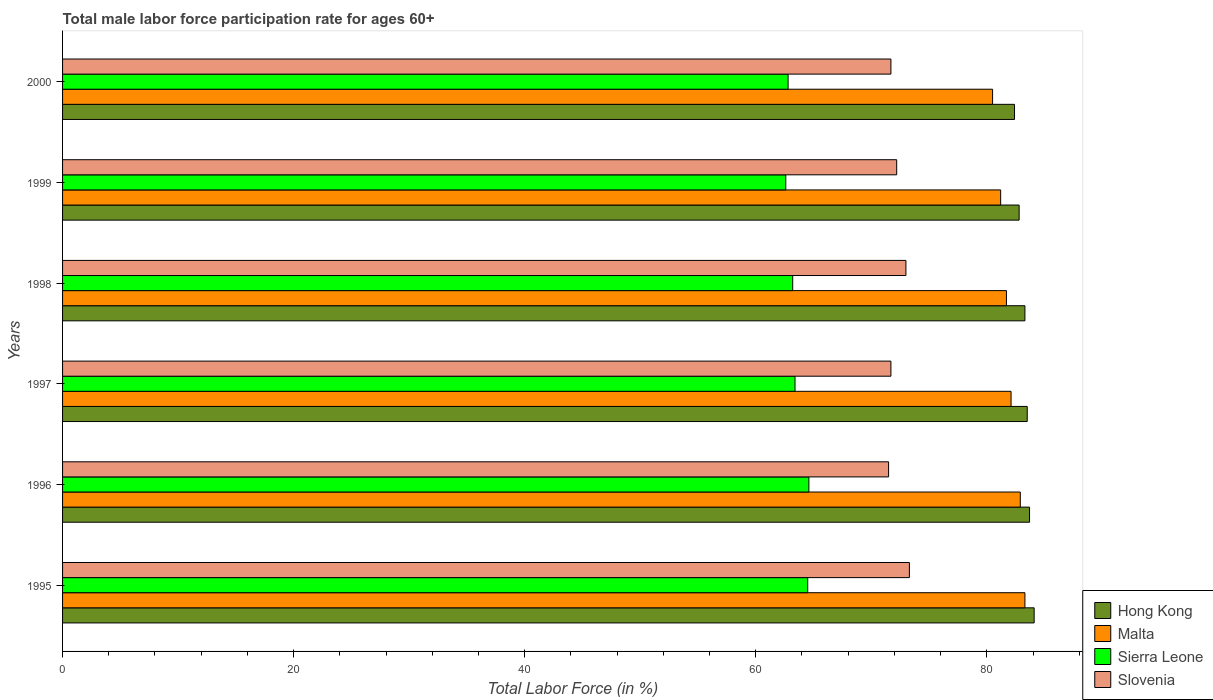Are the number of bars per tick equal to the number of legend labels?
Offer a terse response. Yes. How many bars are there on the 6th tick from the bottom?
Your answer should be compact. 4. What is the male labor force participation rate in Sierra Leone in 1996?
Ensure brevity in your answer.  64.6. Across all years, what is the maximum male labor force participation rate in Malta?
Give a very brief answer. 83.3. Across all years, what is the minimum male labor force participation rate in Hong Kong?
Keep it short and to the point. 82.4. In which year was the male labor force participation rate in Malta minimum?
Make the answer very short. 2000. What is the total male labor force participation rate in Slovenia in the graph?
Your answer should be very brief. 433.4. What is the difference between the male labor force participation rate in Sierra Leone in 1995 and that in 1999?
Make the answer very short. 1.9. What is the difference between the male labor force participation rate in Malta in 1996 and the male labor force participation rate in Sierra Leone in 1995?
Your response must be concise. 18.4. What is the average male labor force participation rate in Sierra Leone per year?
Your answer should be very brief. 63.52. In the year 1996, what is the difference between the male labor force participation rate in Sierra Leone and male labor force participation rate in Hong Kong?
Ensure brevity in your answer.  -19.1. What is the ratio of the male labor force participation rate in Malta in 1995 to that in 1998?
Give a very brief answer. 1.02. Is the male labor force participation rate in Sierra Leone in 1997 less than that in 2000?
Make the answer very short. No. What is the difference between the highest and the second highest male labor force participation rate in Sierra Leone?
Provide a succinct answer. 0.1. What is the difference between the highest and the lowest male labor force participation rate in Sierra Leone?
Make the answer very short. 2. Is the sum of the male labor force participation rate in Hong Kong in 1995 and 1997 greater than the maximum male labor force participation rate in Slovenia across all years?
Offer a terse response. Yes. What does the 1st bar from the top in 1997 represents?
Offer a terse response. Slovenia. What does the 4th bar from the bottom in 1995 represents?
Provide a succinct answer. Slovenia. How many bars are there?
Your answer should be compact. 24. How many years are there in the graph?
Your response must be concise. 6. Are the values on the major ticks of X-axis written in scientific E-notation?
Provide a short and direct response. No. Where does the legend appear in the graph?
Your response must be concise. Bottom right. How many legend labels are there?
Provide a succinct answer. 4. How are the legend labels stacked?
Your answer should be compact. Vertical. What is the title of the graph?
Provide a short and direct response. Total male labor force participation rate for ages 60+. What is the label or title of the X-axis?
Provide a short and direct response. Total Labor Force (in %). What is the label or title of the Y-axis?
Ensure brevity in your answer.  Years. What is the Total Labor Force (in %) of Hong Kong in 1995?
Offer a very short reply. 84.1. What is the Total Labor Force (in %) of Malta in 1995?
Give a very brief answer. 83.3. What is the Total Labor Force (in %) in Sierra Leone in 1995?
Your answer should be compact. 64.5. What is the Total Labor Force (in %) in Slovenia in 1995?
Your response must be concise. 73.3. What is the Total Labor Force (in %) in Hong Kong in 1996?
Your answer should be very brief. 83.7. What is the Total Labor Force (in %) in Malta in 1996?
Your response must be concise. 82.9. What is the Total Labor Force (in %) of Sierra Leone in 1996?
Provide a short and direct response. 64.6. What is the Total Labor Force (in %) in Slovenia in 1996?
Keep it short and to the point. 71.5. What is the Total Labor Force (in %) of Hong Kong in 1997?
Your response must be concise. 83.5. What is the Total Labor Force (in %) in Malta in 1997?
Your response must be concise. 82.1. What is the Total Labor Force (in %) of Sierra Leone in 1997?
Give a very brief answer. 63.4. What is the Total Labor Force (in %) of Slovenia in 1997?
Ensure brevity in your answer.  71.7. What is the Total Labor Force (in %) of Hong Kong in 1998?
Provide a short and direct response. 83.3. What is the Total Labor Force (in %) in Malta in 1998?
Offer a very short reply. 81.7. What is the Total Labor Force (in %) in Sierra Leone in 1998?
Your response must be concise. 63.2. What is the Total Labor Force (in %) of Slovenia in 1998?
Provide a succinct answer. 73. What is the Total Labor Force (in %) in Hong Kong in 1999?
Your answer should be very brief. 82.8. What is the Total Labor Force (in %) of Malta in 1999?
Provide a succinct answer. 81.2. What is the Total Labor Force (in %) of Sierra Leone in 1999?
Your answer should be very brief. 62.6. What is the Total Labor Force (in %) of Slovenia in 1999?
Make the answer very short. 72.2. What is the Total Labor Force (in %) of Hong Kong in 2000?
Provide a short and direct response. 82.4. What is the Total Labor Force (in %) in Malta in 2000?
Ensure brevity in your answer.  80.5. What is the Total Labor Force (in %) of Sierra Leone in 2000?
Make the answer very short. 62.8. What is the Total Labor Force (in %) of Slovenia in 2000?
Your answer should be very brief. 71.7. Across all years, what is the maximum Total Labor Force (in %) in Hong Kong?
Offer a terse response. 84.1. Across all years, what is the maximum Total Labor Force (in %) of Malta?
Your answer should be very brief. 83.3. Across all years, what is the maximum Total Labor Force (in %) of Sierra Leone?
Give a very brief answer. 64.6. Across all years, what is the maximum Total Labor Force (in %) of Slovenia?
Keep it short and to the point. 73.3. Across all years, what is the minimum Total Labor Force (in %) of Hong Kong?
Keep it short and to the point. 82.4. Across all years, what is the minimum Total Labor Force (in %) in Malta?
Offer a terse response. 80.5. Across all years, what is the minimum Total Labor Force (in %) in Sierra Leone?
Provide a short and direct response. 62.6. Across all years, what is the minimum Total Labor Force (in %) in Slovenia?
Ensure brevity in your answer.  71.5. What is the total Total Labor Force (in %) of Hong Kong in the graph?
Provide a succinct answer. 499.8. What is the total Total Labor Force (in %) of Malta in the graph?
Your answer should be compact. 491.7. What is the total Total Labor Force (in %) in Sierra Leone in the graph?
Ensure brevity in your answer.  381.1. What is the total Total Labor Force (in %) in Slovenia in the graph?
Your answer should be very brief. 433.4. What is the difference between the Total Labor Force (in %) in Hong Kong in 1995 and that in 1998?
Keep it short and to the point. 0.8. What is the difference between the Total Labor Force (in %) in Malta in 1995 and that in 1998?
Your answer should be compact. 1.6. What is the difference between the Total Labor Force (in %) in Sierra Leone in 1995 and that in 1998?
Provide a short and direct response. 1.3. What is the difference between the Total Labor Force (in %) in Hong Kong in 1995 and that in 1999?
Keep it short and to the point. 1.3. What is the difference between the Total Labor Force (in %) of Sierra Leone in 1995 and that in 1999?
Your answer should be compact. 1.9. What is the difference between the Total Labor Force (in %) in Hong Kong in 1995 and that in 2000?
Ensure brevity in your answer.  1.7. What is the difference between the Total Labor Force (in %) of Hong Kong in 1996 and that in 1997?
Your response must be concise. 0.2. What is the difference between the Total Labor Force (in %) of Sierra Leone in 1996 and that in 1998?
Offer a terse response. 1.4. What is the difference between the Total Labor Force (in %) in Hong Kong in 1996 and that in 1999?
Your response must be concise. 0.9. What is the difference between the Total Labor Force (in %) of Malta in 1996 and that in 1999?
Your answer should be compact. 1.7. What is the difference between the Total Labor Force (in %) of Hong Kong in 1996 and that in 2000?
Offer a terse response. 1.3. What is the difference between the Total Labor Force (in %) of Malta in 1996 and that in 2000?
Your response must be concise. 2.4. What is the difference between the Total Labor Force (in %) of Malta in 1997 and that in 1998?
Your answer should be very brief. 0.4. What is the difference between the Total Labor Force (in %) in Sierra Leone in 1997 and that in 1998?
Give a very brief answer. 0.2. What is the difference between the Total Labor Force (in %) in Slovenia in 1997 and that in 1999?
Your answer should be compact. -0.5. What is the difference between the Total Labor Force (in %) in Hong Kong in 1997 and that in 2000?
Give a very brief answer. 1.1. What is the difference between the Total Labor Force (in %) of Malta in 1997 and that in 2000?
Your answer should be very brief. 1.6. What is the difference between the Total Labor Force (in %) in Sierra Leone in 1997 and that in 2000?
Ensure brevity in your answer.  0.6. What is the difference between the Total Labor Force (in %) of Hong Kong in 1998 and that in 1999?
Give a very brief answer. 0.5. What is the difference between the Total Labor Force (in %) of Malta in 1998 and that in 1999?
Make the answer very short. 0.5. What is the difference between the Total Labor Force (in %) in Hong Kong in 1998 and that in 2000?
Make the answer very short. 0.9. What is the difference between the Total Labor Force (in %) of Malta in 1998 and that in 2000?
Your response must be concise. 1.2. What is the difference between the Total Labor Force (in %) in Sierra Leone in 1998 and that in 2000?
Give a very brief answer. 0.4. What is the difference between the Total Labor Force (in %) of Slovenia in 1998 and that in 2000?
Offer a terse response. 1.3. What is the difference between the Total Labor Force (in %) of Hong Kong in 1999 and that in 2000?
Your response must be concise. 0.4. What is the difference between the Total Labor Force (in %) in Malta in 1999 and that in 2000?
Make the answer very short. 0.7. What is the difference between the Total Labor Force (in %) of Hong Kong in 1995 and the Total Labor Force (in %) of Malta in 1996?
Your answer should be very brief. 1.2. What is the difference between the Total Labor Force (in %) of Hong Kong in 1995 and the Total Labor Force (in %) of Slovenia in 1996?
Your response must be concise. 12.6. What is the difference between the Total Labor Force (in %) of Malta in 1995 and the Total Labor Force (in %) of Sierra Leone in 1996?
Keep it short and to the point. 18.7. What is the difference between the Total Labor Force (in %) in Sierra Leone in 1995 and the Total Labor Force (in %) in Slovenia in 1996?
Make the answer very short. -7. What is the difference between the Total Labor Force (in %) in Hong Kong in 1995 and the Total Labor Force (in %) in Sierra Leone in 1997?
Make the answer very short. 20.7. What is the difference between the Total Labor Force (in %) of Hong Kong in 1995 and the Total Labor Force (in %) of Slovenia in 1997?
Make the answer very short. 12.4. What is the difference between the Total Labor Force (in %) in Hong Kong in 1995 and the Total Labor Force (in %) in Malta in 1998?
Give a very brief answer. 2.4. What is the difference between the Total Labor Force (in %) in Hong Kong in 1995 and the Total Labor Force (in %) in Sierra Leone in 1998?
Your answer should be very brief. 20.9. What is the difference between the Total Labor Force (in %) of Hong Kong in 1995 and the Total Labor Force (in %) of Slovenia in 1998?
Your answer should be compact. 11.1. What is the difference between the Total Labor Force (in %) of Malta in 1995 and the Total Labor Force (in %) of Sierra Leone in 1998?
Provide a succinct answer. 20.1. What is the difference between the Total Labor Force (in %) in Malta in 1995 and the Total Labor Force (in %) in Slovenia in 1998?
Offer a very short reply. 10.3. What is the difference between the Total Labor Force (in %) in Sierra Leone in 1995 and the Total Labor Force (in %) in Slovenia in 1998?
Give a very brief answer. -8.5. What is the difference between the Total Labor Force (in %) in Hong Kong in 1995 and the Total Labor Force (in %) in Malta in 1999?
Ensure brevity in your answer.  2.9. What is the difference between the Total Labor Force (in %) of Hong Kong in 1995 and the Total Labor Force (in %) of Sierra Leone in 1999?
Provide a succinct answer. 21.5. What is the difference between the Total Labor Force (in %) of Hong Kong in 1995 and the Total Labor Force (in %) of Slovenia in 1999?
Provide a succinct answer. 11.9. What is the difference between the Total Labor Force (in %) in Malta in 1995 and the Total Labor Force (in %) in Sierra Leone in 1999?
Keep it short and to the point. 20.7. What is the difference between the Total Labor Force (in %) in Malta in 1995 and the Total Labor Force (in %) in Slovenia in 1999?
Your answer should be very brief. 11.1. What is the difference between the Total Labor Force (in %) in Sierra Leone in 1995 and the Total Labor Force (in %) in Slovenia in 1999?
Your answer should be compact. -7.7. What is the difference between the Total Labor Force (in %) in Hong Kong in 1995 and the Total Labor Force (in %) in Sierra Leone in 2000?
Keep it short and to the point. 21.3. What is the difference between the Total Labor Force (in %) in Malta in 1995 and the Total Labor Force (in %) in Slovenia in 2000?
Offer a terse response. 11.6. What is the difference between the Total Labor Force (in %) in Sierra Leone in 1995 and the Total Labor Force (in %) in Slovenia in 2000?
Provide a short and direct response. -7.2. What is the difference between the Total Labor Force (in %) of Hong Kong in 1996 and the Total Labor Force (in %) of Sierra Leone in 1997?
Keep it short and to the point. 20.3. What is the difference between the Total Labor Force (in %) in Hong Kong in 1996 and the Total Labor Force (in %) in Malta in 1998?
Your answer should be compact. 2. What is the difference between the Total Labor Force (in %) in Malta in 1996 and the Total Labor Force (in %) in Slovenia in 1998?
Your response must be concise. 9.9. What is the difference between the Total Labor Force (in %) in Sierra Leone in 1996 and the Total Labor Force (in %) in Slovenia in 1998?
Your response must be concise. -8.4. What is the difference between the Total Labor Force (in %) in Hong Kong in 1996 and the Total Labor Force (in %) in Malta in 1999?
Keep it short and to the point. 2.5. What is the difference between the Total Labor Force (in %) of Hong Kong in 1996 and the Total Labor Force (in %) of Sierra Leone in 1999?
Provide a succinct answer. 21.1. What is the difference between the Total Labor Force (in %) of Malta in 1996 and the Total Labor Force (in %) of Sierra Leone in 1999?
Offer a terse response. 20.3. What is the difference between the Total Labor Force (in %) in Malta in 1996 and the Total Labor Force (in %) in Slovenia in 1999?
Provide a succinct answer. 10.7. What is the difference between the Total Labor Force (in %) in Hong Kong in 1996 and the Total Labor Force (in %) in Sierra Leone in 2000?
Your answer should be compact. 20.9. What is the difference between the Total Labor Force (in %) in Hong Kong in 1996 and the Total Labor Force (in %) in Slovenia in 2000?
Make the answer very short. 12. What is the difference between the Total Labor Force (in %) of Malta in 1996 and the Total Labor Force (in %) of Sierra Leone in 2000?
Give a very brief answer. 20.1. What is the difference between the Total Labor Force (in %) in Malta in 1996 and the Total Labor Force (in %) in Slovenia in 2000?
Your answer should be compact. 11.2. What is the difference between the Total Labor Force (in %) of Hong Kong in 1997 and the Total Labor Force (in %) of Sierra Leone in 1998?
Offer a very short reply. 20.3. What is the difference between the Total Labor Force (in %) of Hong Kong in 1997 and the Total Labor Force (in %) of Malta in 1999?
Your answer should be very brief. 2.3. What is the difference between the Total Labor Force (in %) in Hong Kong in 1997 and the Total Labor Force (in %) in Sierra Leone in 1999?
Offer a terse response. 20.9. What is the difference between the Total Labor Force (in %) of Malta in 1997 and the Total Labor Force (in %) of Sierra Leone in 1999?
Your answer should be compact. 19.5. What is the difference between the Total Labor Force (in %) in Sierra Leone in 1997 and the Total Labor Force (in %) in Slovenia in 1999?
Keep it short and to the point. -8.8. What is the difference between the Total Labor Force (in %) of Hong Kong in 1997 and the Total Labor Force (in %) of Sierra Leone in 2000?
Ensure brevity in your answer.  20.7. What is the difference between the Total Labor Force (in %) of Malta in 1997 and the Total Labor Force (in %) of Sierra Leone in 2000?
Your answer should be compact. 19.3. What is the difference between the Total Labor Force (in %) in Sierra Leone in 1997 and the Total Labor Force (in %) in Slovenia in 2000?
Provide a short and direct response. -8.3. What is the difference between the Total Labor Force (in %) of Hong Kong in 1998 and the Total Labor Force (in %) of Sierra Leone in 1999?
Keep it short and to the point. 20.7. What is the difference between the Total Labor Force (in %) in Sierra Leone in 1998 and the Total Labor Force (in %) in Slovenia in 1999?
Offer a very short reply. -9. What is the difference between the Total Labor Force (in %) of Hong Kong in 1998 and the Total Labor Force (in %) of Malta in 2000?
Your answer should be compact. 2.8. What is the difference between the Total Labor Force (in %) in Hong Kong in 1998 and the Total Labor Force (in %) in Slovenia in 2000?
Your response must be concise. 11.6. What is the difference between the Total Labor Force (in %) in Malta in 1998 and the Total Labor Force (in %) in Slovenia in 2000?
Offer a terse response. 10. What is the difference between the Total Labor Force (in %) in Sierra Leone in 1998 and the Total Labor Force (in %) in Slovenia in 2000?
Make the answer very short. -8.5. What is the difference between the Total Labor Force (in %) in Hong Kong in 1999 and the Total Labor Force (in %) in Sierra Leone in 2000?
Make the answer very short. 20. What is the difference between the Total Labor Force (in %) of Hong Kong in 1999 and the Total Labor Force (in %) of Slovenia in 2000?
Give a very brief answer. 11.1. What is the difference between the Total Labor Force (in %) of Malta in 1999 and the Total Labor Force (in %) of Sierra Leone in 2000?
Offer a very short reply. 18.4. What is the difference between the Total Labor Force (in %) in Malta in 1999 and the Total Labor Force (in %) in Slovenia in 2000?
Keep it short and to the point. 9.5. What is the average Total Labor Force (in %) in Hong Kong per year?
Your answer should be very brief. 83.3. What is the average Total Labor Force (in %) in Malta per year?
Provide a short and direct response. 81.95. What is the average Total Labor Force (in %) of Sierra Leone per year?
Make the answer very short. 63.52. What is the average Total Labor Force (in %) in Slovenia per year?
Ensure brevity in your answer.  72.23. In the year 1995, what is the difference between the Total Labor Force (in %) of Hong Kong and Total Labor Force (in %) of Malta?
Your response must be concise. 0.8. In the year 1995, what is the difference between the Total Labor Force (in %) in Hong Kong and Total Labor Force (in %) in Sierra Leone?
Provide a succinct answer. 19.6. In the year 1995, what is the difference between the Total Labor Force (in %) of Malta and Total Labor Force (in %) of Sierra Leone?
Ensure brevity in your answer.  18.8. In the year 1995, what is the difference between the Total Labor Force (in %) of Sierra Leone and Total Labor Force (in %) of Slovenia?
Give a very brief answer. -8.8. In the year 1996, what is the difference between the Total Labor Force (in %) of Hong Kong and Total Labor Force (in %) of Malta?
Ensure brevity in your answer.  0.8. In the year 1996, what is the difference between the Total Labor Force (in %) of Hong Kong and Total Labor Force (in %) of Slovenia?
Your answer should be very brief. 12.2. In the year 1996, what is the difference between the Total Labor Force (in %) in Malta and Total Labor Force (in %) in Sierra Leone?
Provide a succinct answer. 18.3. In the year 1996, what is the difference between the Total Labor Force (in %) of Malta and Total Labor Force (in %) of Slovenia?
Ensure brevity in your answer.  11.4. In the year 1997, what is the difference between the Total Labor Force (in %) of Hong Kong and Total Labor Force (in %) of Sierra Leone?
Provide a succinct answer. 20.1. In the year 1997, what is the difference between the Total Labor Force (in %) in Hong Kong and Total Labor Force (in %) in Slovenia?
Your answer should be compact. 11.8. In the year 1997, what is the difference between the Total Labor Force (in %) in Malta and Total Labor Force (in %) in Sierra Leone?
Your response must be concise. 18.7. In the year 1997, what is the difference between the Total Labor Force (in %) in Sierra Leone and Total Labor Force (in %) in Slovenia?
Make the answer very short. -8.3. In the year 1998, what is the difference between the Total Labor Force (in %) of Hong Kong and Total Labor Force (in %) of Sierra Leone?
Offer a very short reply. 20.1. In the year 1998, what is the difference between the Total Labor Force (in %) in Hong Kong and Total Labor Force (in %) in Slovenia?
Your answer should be compact. 10.3. In the year 1998, what is the difference between the Total Labor Force (in %) in Malta and Total Labor Force (in %) in Sierra Leone?
Offer a very short reply. 18.5. In the year 1999, what is the difference between the Total Labor Force (in %) of Hong Kong and Total Labor Force (in %) of Sierra Leone?
Your answer should be very brief. 20.2. In the year 1999, what is the difference between the Total Labor Force (in %) in Hong Kong and Total Labor Force (in %) in Slovenia?
Ensure brevity in your answer.  10.6. In the year 1999, what is the difference between the Total Labor Force (in %) in Malta and Total Labor Force (in %) in Slovenia?
Your answer should be very brief. 9. In the year 1999, what is the difference between the Total Labor Force (in %) of Sierra Leone and Total Labor Force (in %) of Slovenia?
Your answer should be compact. -9.6. In the year 2000, what is the difference between the Total Labor Force (in %) of Hong Kong and Total Labor Force (in %) of Sierra Leone?
Offer a very short reply. 19.6. In the year 2000, what is the difference between the Total Labor Force (in %) in Hong Kong and Total Labor Force (in %) in Slovenia?
Offer a terse response. 10.7. In the year 2000, what is the difference between the Total Labor Force (in %) of Malta and Total Labor Force (in %) of Slovenia?
Provide a succinct answer. 8.8. In the year 2000, what is the difference between the Total Labor Force (in %) in Sierra Leone and Total Labor Force (in %) in Slovenia?
Your answer should be compact. -8.9. What is the ratio of the Total Labor Force (in %) in Sierra Leone in 1995 to that in 1996?
Keep it short and to the point. 1. What is the ratio of the Total Labor Force (in %) of Slovenia in 1995 to that in 1996?
Provide a succinct answer. 1.03. What is the ratio of the Total Labor Force (in %) of Malta in 1995 to that in 1997?
Offer a terse response. 1.01. What is the ratio of the Total Labor Force (in %) in Sierra Leone in 1995 to that in 1997?
Your answer should be compact. 1.02. What is the ratio of the Total Labor Force (in %) of Slovenia in 1995 to that in 1997?
Keep it short and to the point. 1.02. What is the ratio of the Total Labor Force (in %) of Hong Kong in 1995 to that in 1998?
Provide a succinct answer. 1.01. What is the ratio of the Total Labor Force (in %) in Malta in 1995 to that in 1998?
Your response must be concise. 1.02. What is the ratio of the Total Labor Force (in %) in Sierra Leone in 1995 to that in 1998?
Give a very brief answer. 1.02. What is the ratio of the Total Labor Force (in %) in Slovenia in 1995 to that in 1998?
Offer a terse response. 1. What is the ratio of the Total Labor Force (in %) of Hong Kong in 1995 to that in 1999?
Provide a succinct answer. 1.02. What is the ratio of the Total Labor Force (in %) of Malta in 1995 to that in 1999?
Give a very brief answer. 1.03. What is the ratio of the Total Labor Force (in %) in Sierra Leone in 1995 to that in 1999?
Your answer should be very brief. 1.03. What is the ratio of the Total Labor Force (in %) of Slovenia in 1995 to that in 1999?
Keep it short and to the point. 1.02. What is the ratio of the Total Labor Force (in %) in Hong Kong in 1995 to that in 2000?
Provide a short and direct response. 1.02. What is the ratio of the Total Labor Force (in %) in Malta in 1995 to that in 2000?
Keep it short and to the point. 1.03. What is the ratio of the Total Labor Force (in %) of Sierra Leone in 1995 to that in 2000?
Offer a terse response. 1.03. What is the ratio of the Total Labor Force (in %) of Slovenia in 1995 to that in 2000?
Your response must be concise. 1.02. What is the ratio of the Total Labor Force (in %) in Hong Kong in 1996 to that in 1997?
Make the answer very short. 1. What is the ratio of the Total Labor Force (in %) in Malta in 1996 to that in 1997?
Offer a terse response. 1.01. What is the ratio of the Total Labor Force (in %) in Sierra Leone in 1996 to that in 1997?
Offer a terse response. 1.02. What is the ratio of the Total Labor Force (in %) of Slovenia in 1996 to that in 1997?
Ensure brevity in your answer.  1. What is the ratio of the Total Labor Force (in %) of Hong Kong in 1996 to that in 1998?
Offer a very short reply. 1. What is the ratio of the Total Labor Force (in %) of Malta in 1996 to that in 1998?
Give a very brief answer. 1.01. What is the ratio of the Total Labor Force (in %) of Sierra Leone in 1996 to that in 1998?
Offer a terse response. 1.02. What is the ratio of the Total Labor Force (in %) of Slovenia in 1996 to that in 1998?
Offer a very short reply. 0.98. What is the ratio of the Total Labor Force (in %) in Hong Kong in 1996 to that in 1999?
Your response must be concise. 1.01. What is the ratio of the Total Labor Force (in %) of Malta in 1996 to that in 1999?
Make the answer very short. 1.02. What is the ratio of the Total Labor Force (in %) of Sierra Leone in 1996 to that in 1999?
Your answer should be very brief. 1.03. What is the ratio of the Total Labor Force (in %) of Slovenia in 1996 to that in 1999?
Your answer should be very brief. 0.99. What is the ratio of the Total Labor Force (in %) of Hong Kong in 1996 to that in 2000?
Your response must be concise. 1.02. What is the ratio of the Total Labor Force (in %) in Malta in 1996 to that in 2000?
Offer a very short reply. 1.03. What is the ratio of the Total Labor Force (in %) of Sierra Leone in 1996 to that in 2000?
Ensure brevity in your answer.  1.03. What is the ratio of the Total Labor Force (in %) in Hong Kong in 1997 to that in 1998?
Your response must be concise. 1. What is the ratio of the Total Labor Force (in %) in Malta in 1997 to that in 1998?
Offer a very short reply. 1. What is the ratio of the Total Labor Force (in %) in Sierra Leone in 1997 to that in 1998?
Make the answer very short. 1. What is the ratio of the Total Labor Force (in %) of Slovenia in 1997 to that in 1998?
Make the answer very short. 0.98. What is the ratio of the Total Labor Force (in %) of Hong Kong in 1997 to that in 1999?
Keep it short and to the point. 1.01. What is the ratio of the Total Labor Force (in %) of Malta in 1997 to that in 1999?
Make the answer very short. 1.01. What is the ratio of the Total Labor Force (in %) in Sierra Leone in 1997 to that in 1999?
Ensure brevity in your answer.  1.01. What is the ratio of the Total Labor Force (in %) of Slovenia in 1997 to that in 1999?
Provide a succinct answer. 0.99. What is the ratio of the Total Labor Force (in %) of Hong Kong in 1997 to that in 2000?
Keep it short and to the point. 1.01. What is the ratio of the Total Labor Force (in %) of Malta in 1997 to that in 2000?
Offer a very short reply. 1.02. What is the ratio of the Total Labor Force (in %) of Sierra Leone in 1997 to that in 2000?
Give a very brief answer. 1.01. What is the ratio of the Total Labor Force (in %) in Slovenia in 1997 to that in 2000?
Your response must be concise. 1. What is the ratio of the Total Labor Force (in %) in Sierra Leone in 1998 to that in 1999?
Give a very brief answer. 1.01. What is the ratio of the Total Labor Force (in %) of Slovenia in 1998 to that in 1999?
Offer a terse response. 1.01. What is the ratio of the Total Labor Force (in %) in Hong Kong in 1998 to that in 2000?
Provide a succinct answer. 1.01. What is the ratio of the Total Labor Force (in %) in Malta in 1998 to that in 2000?
Keep it short and to the point. 1.01. What is the ratio of the Total Labor Force (in %) of Sierra Leone in 1998 to that in 2000?
Provide a short and direct response. 1.01. What is the ratio of the Total Labor Force (in %) in Slovenia in 1998 to that in 2000?
Provide a short and direct response. 1.02. What is the ratio of the Total Labor Force (in %) in Hong Kong in 1999 to that in 2000?
Your answer should be compact. 1. What is the ratio of the Total Labor Force (in %) of Malta in 1999 to that in 2000?
Offer a terse response. 1.01. What is the difference between the highest and the second highest Total Labor Force (in %) in Malta?
Your answer should be compact. 0.4. What is the difference between the highest and the second highest Total Labor Force (in %) of Slovenia?
Your response must be concise. 0.3. What is the difference between the highest and the lowest Total Labor Force (in %) of Malta?
Ensure brevity in your answer.  2.8. 